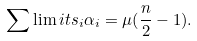<formula> <loc_0><loc_0><loc_500><loc_500>\sum \lim i t s _ { i } \alpha _ { i } = \mu ( \frac { n } { 2 } - 1 ) .</formula> 